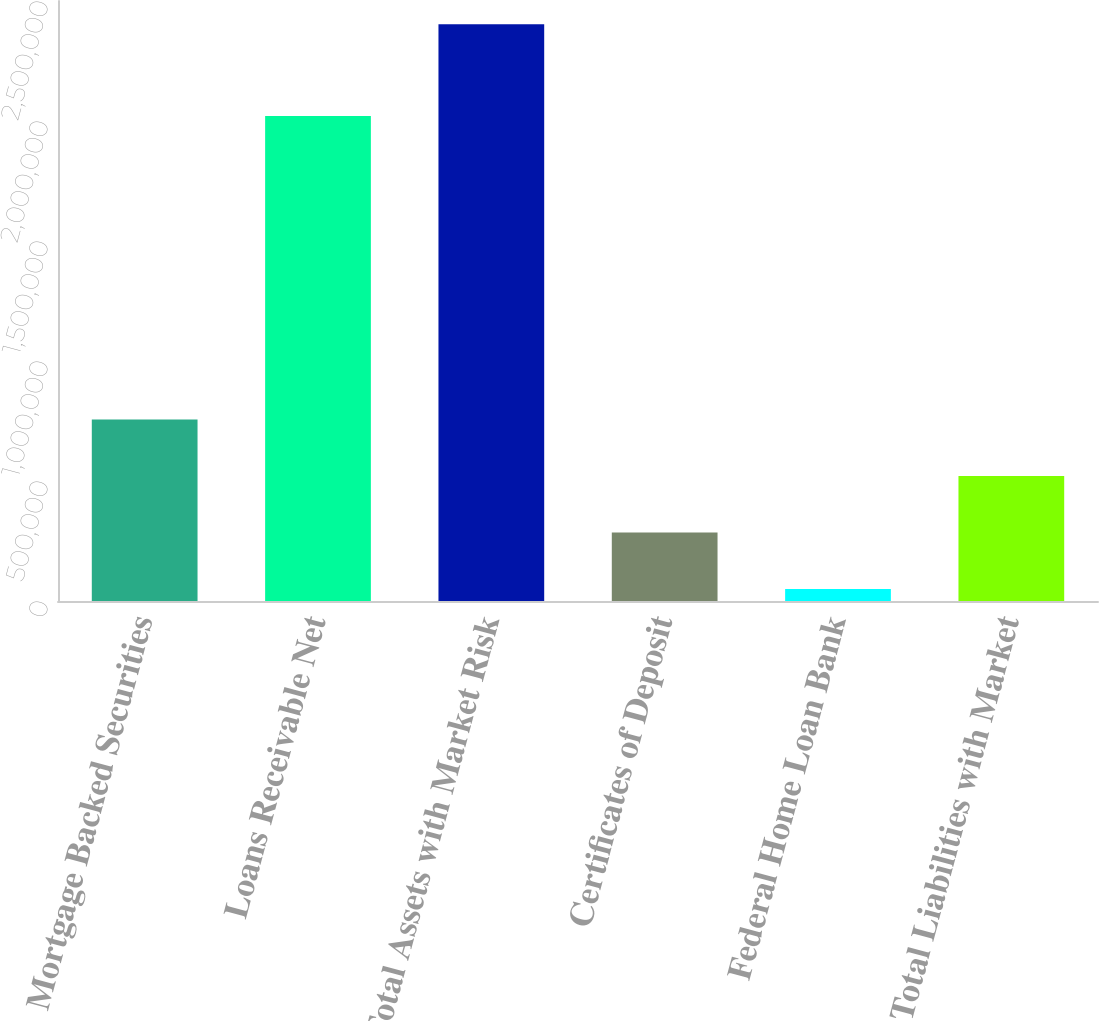Convert chart. <chart><loc_0><loc_0><loc_500><loc_500><bar_chart><fcel>Mortgage Backed Securities<fcel>Loans Receivable Net<fcel>Total Assets with Market Risk<fcel>Certificates of Deposit<fcel>Federal Home Loan Bank<fcel>Total Liabilities with Market<nl><fcel>755896<fcel>2.02053e+06<fcel>2.40298e+06<fcel>285298<fcel>50000<fcel>520597<nl></chart> 